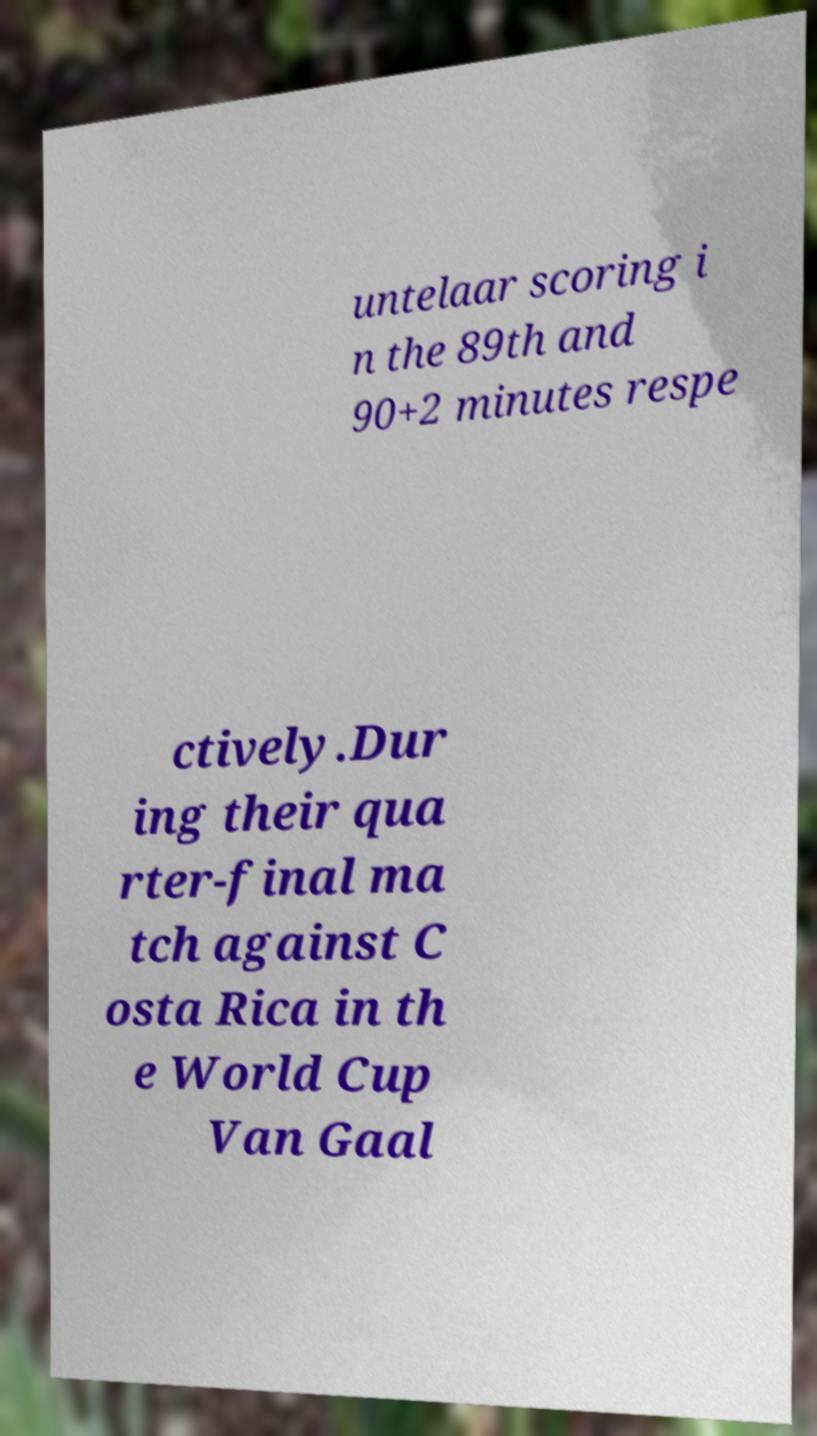What messages or text are displayed in this image? I need them in a readable, typed format. untelaar scoring i n the 89th and 90+2 minutes respe ctively.Dur ing their qua rter-final ma tch against C osta Rica in th e World Cup Van Gaal 